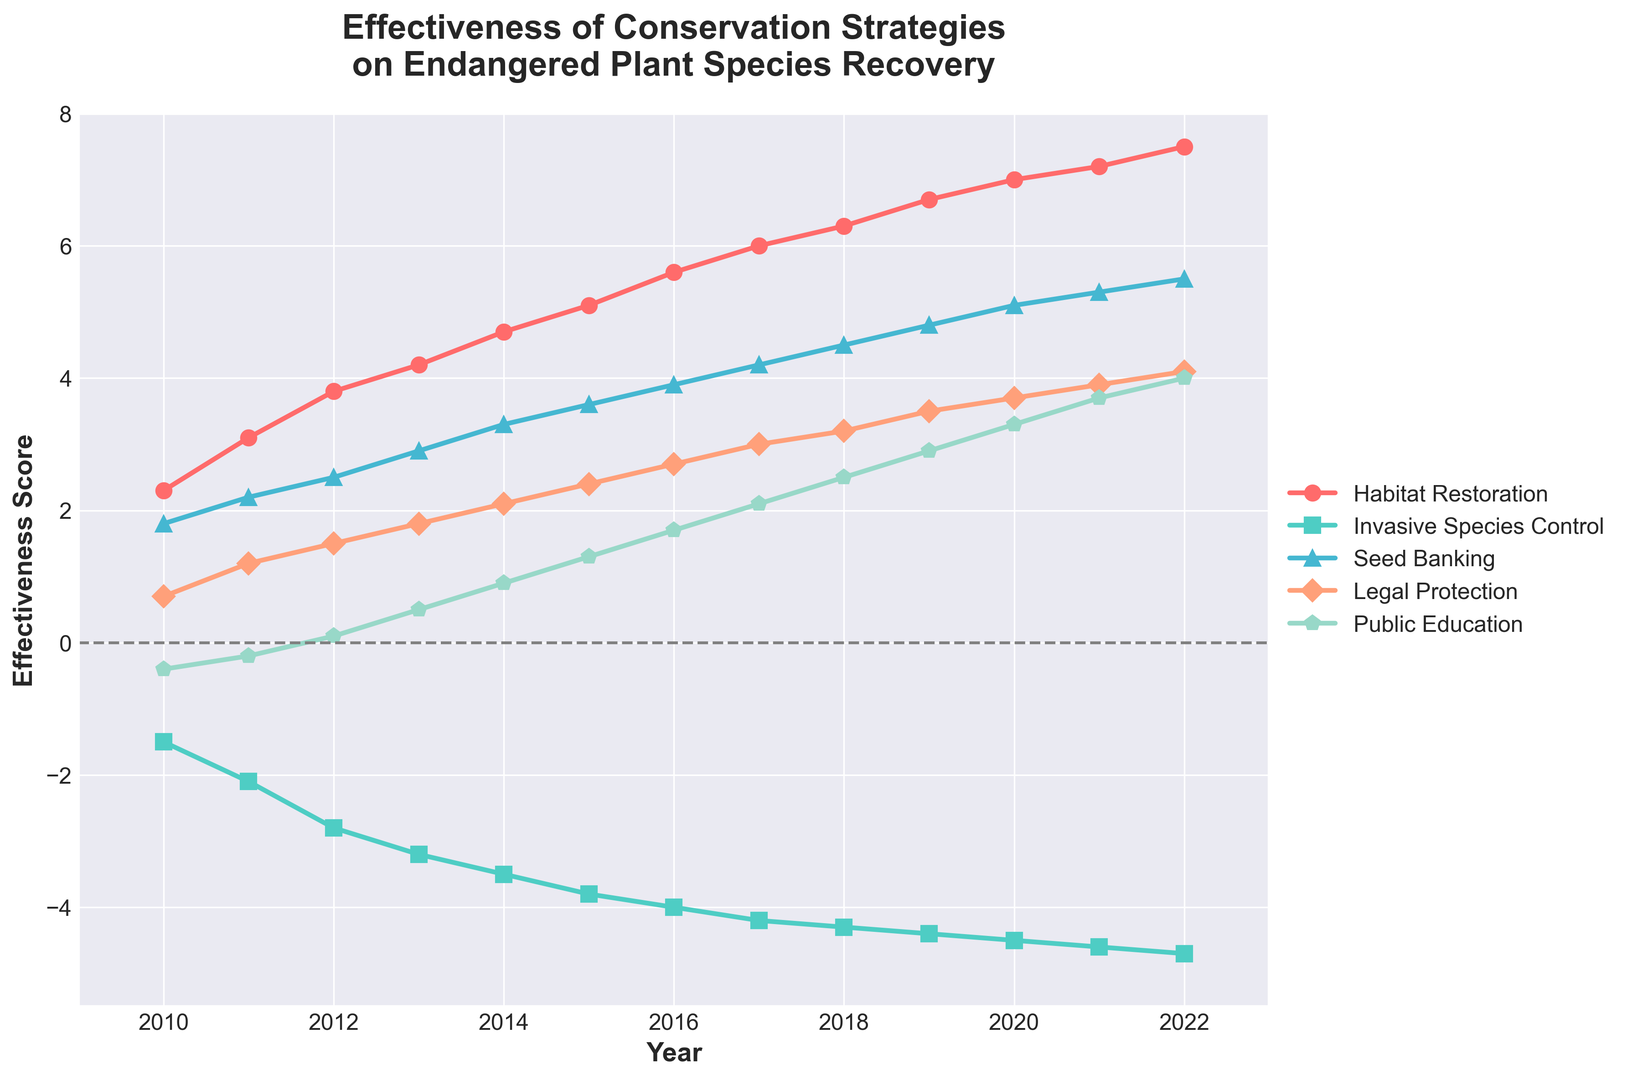What's the overall trend for "Habitat Restoration" from 2010 to 2022? The line for "Habitat Restoration" consistently increases from 2010 to 2022. This positive trend indicates that the effectiveness of this strategy has been improving over the years.
Answer: Increasing Which strategy has the most negative effectiveness score consistently? By observing the lines in the chart, "Invasive Species Control" has the most negative effectiveness score consistently, as its line is below zero throughout the period from 2010 to 2022.
Answer: Invasive Species Control In what year did "Public Education" first achieve a positive effectiveness score? The line for "Public Education" crosses the zero line between the years 2011 and 2012. It only reaches a stable positive score starting from 2012.
Answer: 2012 Which strategies show consistent positive trends from start to end? By examining the slopes of the lines, "Habitat Restoration", "Seed Banking", "Legal Protection", and "Public Education" all show consistent positive trends from 2010 to 2022.
Answer: Habitat Restoration, Seed Banking, Legal Protection, Public Education How does the effectiveness score of "Legal Protection" in 2022 compare to 2010? The effectiveness score of "Legal Protection" in 2022 is 4.1 and in 2010 it was 0.7. The difference is 4.1 - 0.7 = 3.4. This shows that "Legal Protection" has significantly improved over the years.
Answer: 3.4 units increase Which year shows the biggest effectiveness score difference between "Habitat Restoration" and "Invasive Species Control"? To find this, we look for the year with the largest vertical distance between the two lines. In 2022, "Habitat Restoration" is 7.5 and "Invasive Species Control" is -4.7, resulting in a difference of 7.5 - (-4.7) = 12.2, the largest gap observed.
Answer: 2022 What is the average effectiveness score of "Seed Banking" from 2010 to 2022? Sum the effectiveness scores of "Seed Banking" from 2010 to 2022 and divide by the number of years (13 years). The sum is (1.8 + 2.2 + 2.5 + 2.9 + 3.3 + 3.6 + 3.9 + 4.2 + 4.5 + 4.8 + 5.1 + 5.3 + 5.5) = 49.6. The average is 49.6 / 13 ≈ 3.82.
Answer: 3.82 By how much did the effectiveness score of "Public Education" increase from 2010 to 2022? The score increases from -0.4 in 2010 to 4.0 in 2022. The difference is 4.0 - (-0.4) = 4.4.
Answer: 4.4 units Which strategy has the highest final score in 2022? By looking at the points in 2022, "Habitat Restoration" has the highest score of 7.5.
Answer: Habitat Restoration Which year did "Seed Banking" surpass an effectiveness score of 4? The line for "Seed Banking" surpasses the value of 4 between 2017 and 2018. It first reaches above 4 in 2017 with a score of around 4.2.
Answer: 2017 